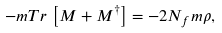Convert formula to latex. <formula><loc_0><loc_0><loc_500><loc_500>- m T r \, \left [ M + M ^ { \dagger } \right ] = - 2 N _ { f } m \rho ,</formula> 